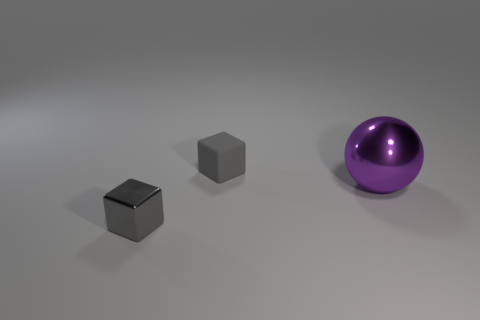Do the small object that is in front of the matte object and the small rubber object have the same color?
Make the answer very short. Yes. Are there any other things that are the same shape as the purple thing?
Your answer should be compact. No. There is a gray object that is in front of the gray rubber thing; what is it made of?
Offer a terse response. Metal. What color is the big metallic object?
Offer a terse response. Purple. There is a gray object left of the rubber cube; is it the same size as the rubber object?
Your answer should be compact. Yes. What material is the block behind the purple metallic object that is behind the shiny thing in front of the large purple metal ball?
Your answer should be very brief. Rubber. There is a cube right of the small gray metallic thing; is it the same color as the object that is in front of the big object?
Provide a short and direct response. Yes. What is the gray cube in front of the small block behind the big ball made of?
Give a very brief answer. Metal. There is a rubber thing that is the same size as the gray metallic block; what color is it?
Your response must be concise. Gray. There is a small shiny thing; is its shape the same as the object behind the big thing?
Your response must be concise. Yes. 